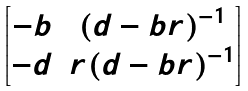<formula> <loc_0><loc_0><loc_500><loc_500>\begin{bmatrix} - b & ( d - b r ) ^ { - 1 } \\ - d & r ( d - b r ) ^ { - 1 } \end{bmatrix}</formula> 